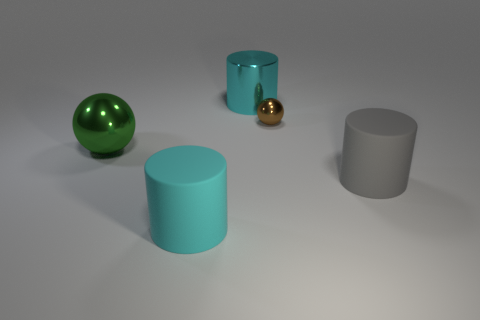What could be the purpose of this arrangement of objects? This arrangement is likely to demonstrate a visual study or comparison of geometric forms and material textures. It could be a render from a 3D modeling software, used to show how different surfaces interact with a light source, or it might be part of a design concept, artistically placed to create an aesthetically pleasing composition. 